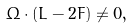<formula> <loc_0><loc_0><loc_500><loc_500>\Omega \cdot ( L - 2 F ) \ne 0 ,</formula> 